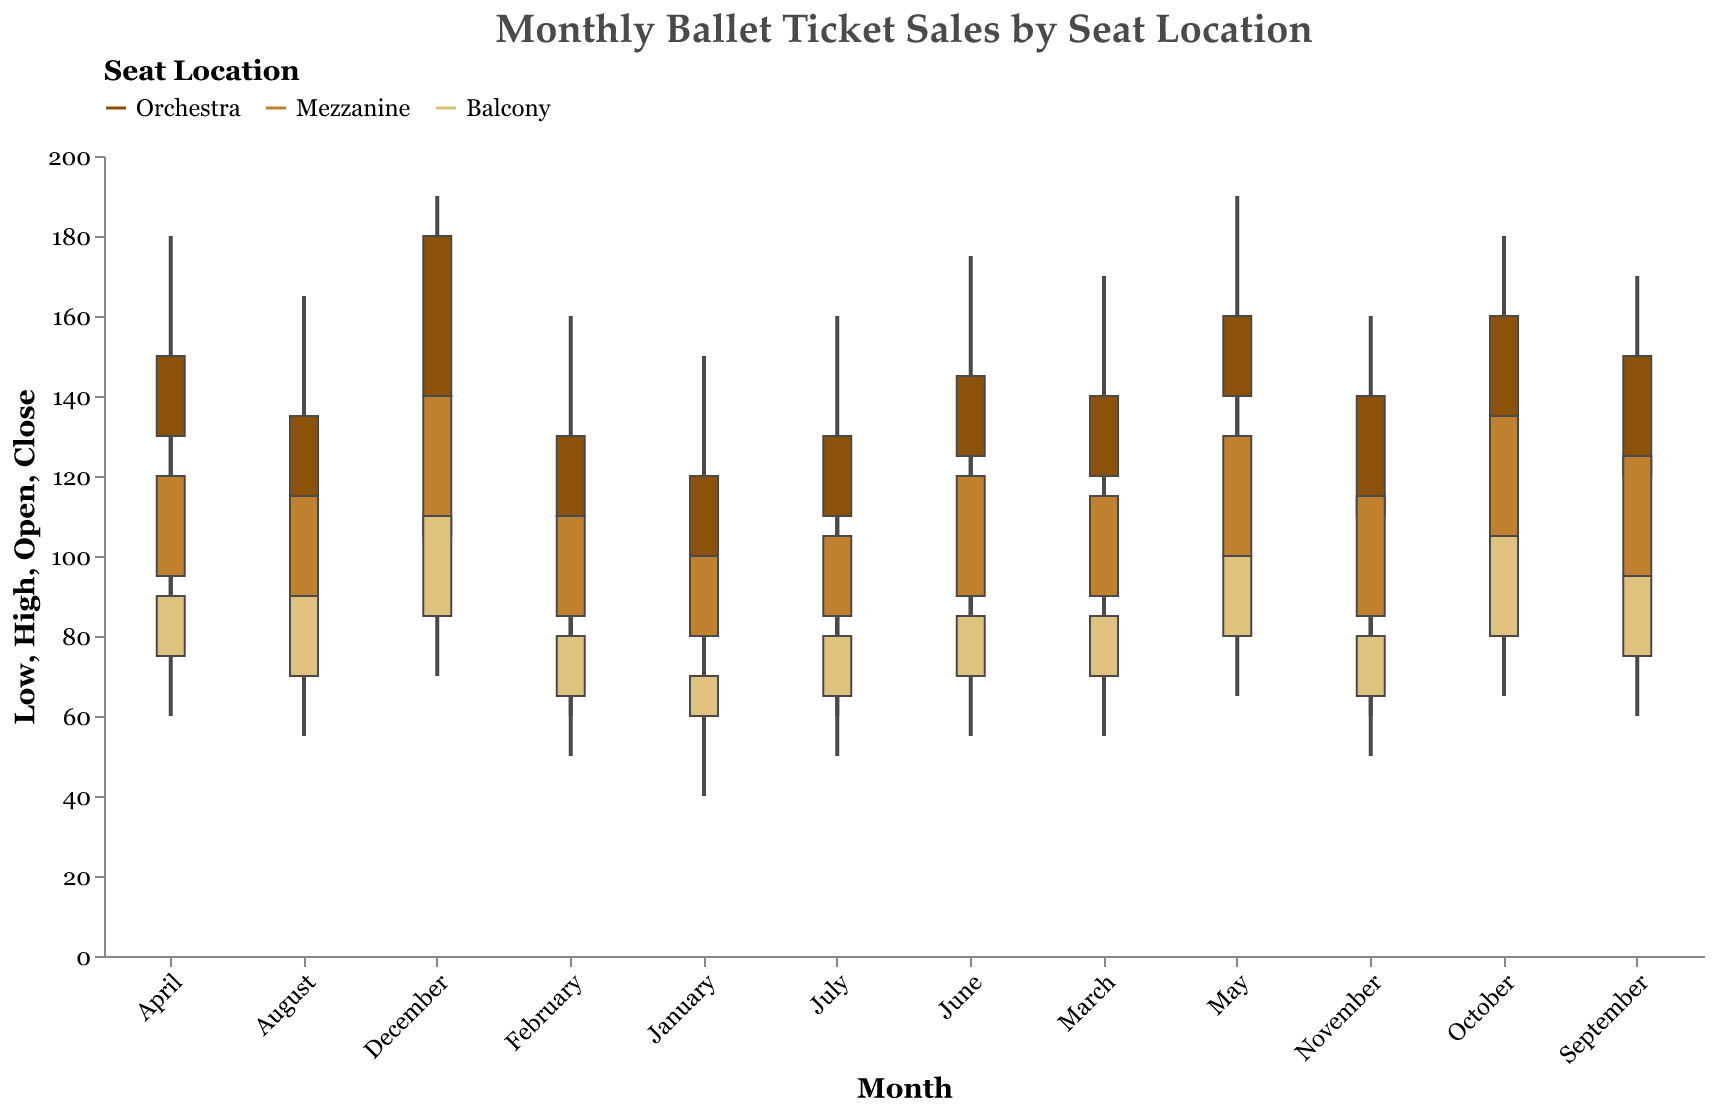How many seat locations are represented in the figure? The figure shows three distinct colors representing three seat locations. These are listed in the legend: Orchestra, Mezzanine, and Balcony.
Answer: Three Which month had the highest closing ticket price for the Orchestra seat location? By inspecting the "Close" values for the Orchestra seat location across all months, we find that December had the highest closing ticket price at 180.
Answer: December What is the range (difference between high and low prices) for Mezzanine seats in April? For Mezzanine seats in April, the high price is 140 and the low price is 75. The range is calculated as 140 - 75.
Answer: 65 Which seat location consistently shows the highest ticket prices throughout the months? By comparing the high prices across the three seat locations for each month, it is consistently the Orchestra that reaches the highest price levels.
Answer: Orchestra What was the closing ticket price for Balcony seats in September? Inspecting the candlestick plot for the Balcony in September reveals the closing ticket price at 95.
Answer: 95 Is there any month where the ticket price for Balcony seats closes higher than Mezzanine seats? By comparing the closing prices for Balcony and Mezzanine seats, we see that no month has Balcony prices closing higher than Mezzanine prices.
Answer: No During which month did the Orchestra seat location experience the widest price range (difference between high and low prices)? The widest range for the Orchestra seat location can be observed by finding the maximum difference between the high and low prices. In May, the range is 190 - 100 = 90, which is the widest.
Answer: May Compare the closing prices of Balcony seats in January and February. Which month had a higher closing price? The closing price for Balcony seats in January is 70, whereas in February it is 80. February has a higher closing price.
Answer: February Which seat location had the lowest low price in July, and what was that price? Looking at the low prices for each seat location in July, the Balcony seats had the lowest price at 50.
Answer: Balcony, 50 For the month of December, what was the average closing price across all seat locations? In December, the closing prices are: Orchestra 180, Mezzanine 140, and Balcony 110. The average is calculated as (180 + 140 + 110) / 3.
Answer: 143.33 